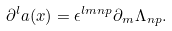<formula> <loc_0><loc_0><loc_500><loc_500>\partial ^ { l } a ( x ) = \epsilon ^ { l m n p } \partial _ { m } \Lambda _ { n p } .</formula> 